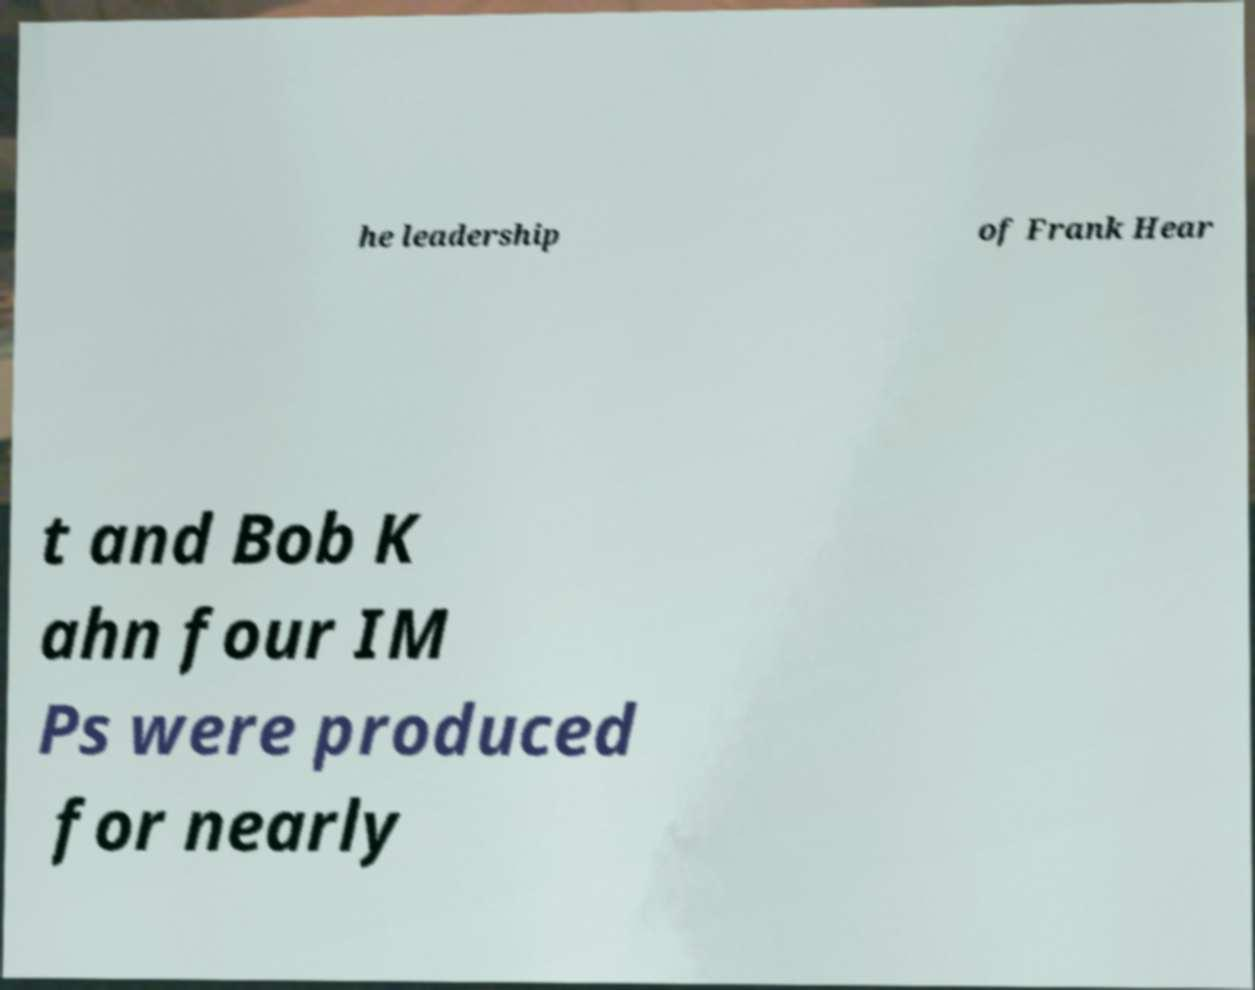Please identify and transcribe the text found in this image. he leadership of Frank Hear t and Bob K ahn four IM Ps were produced for nearly 